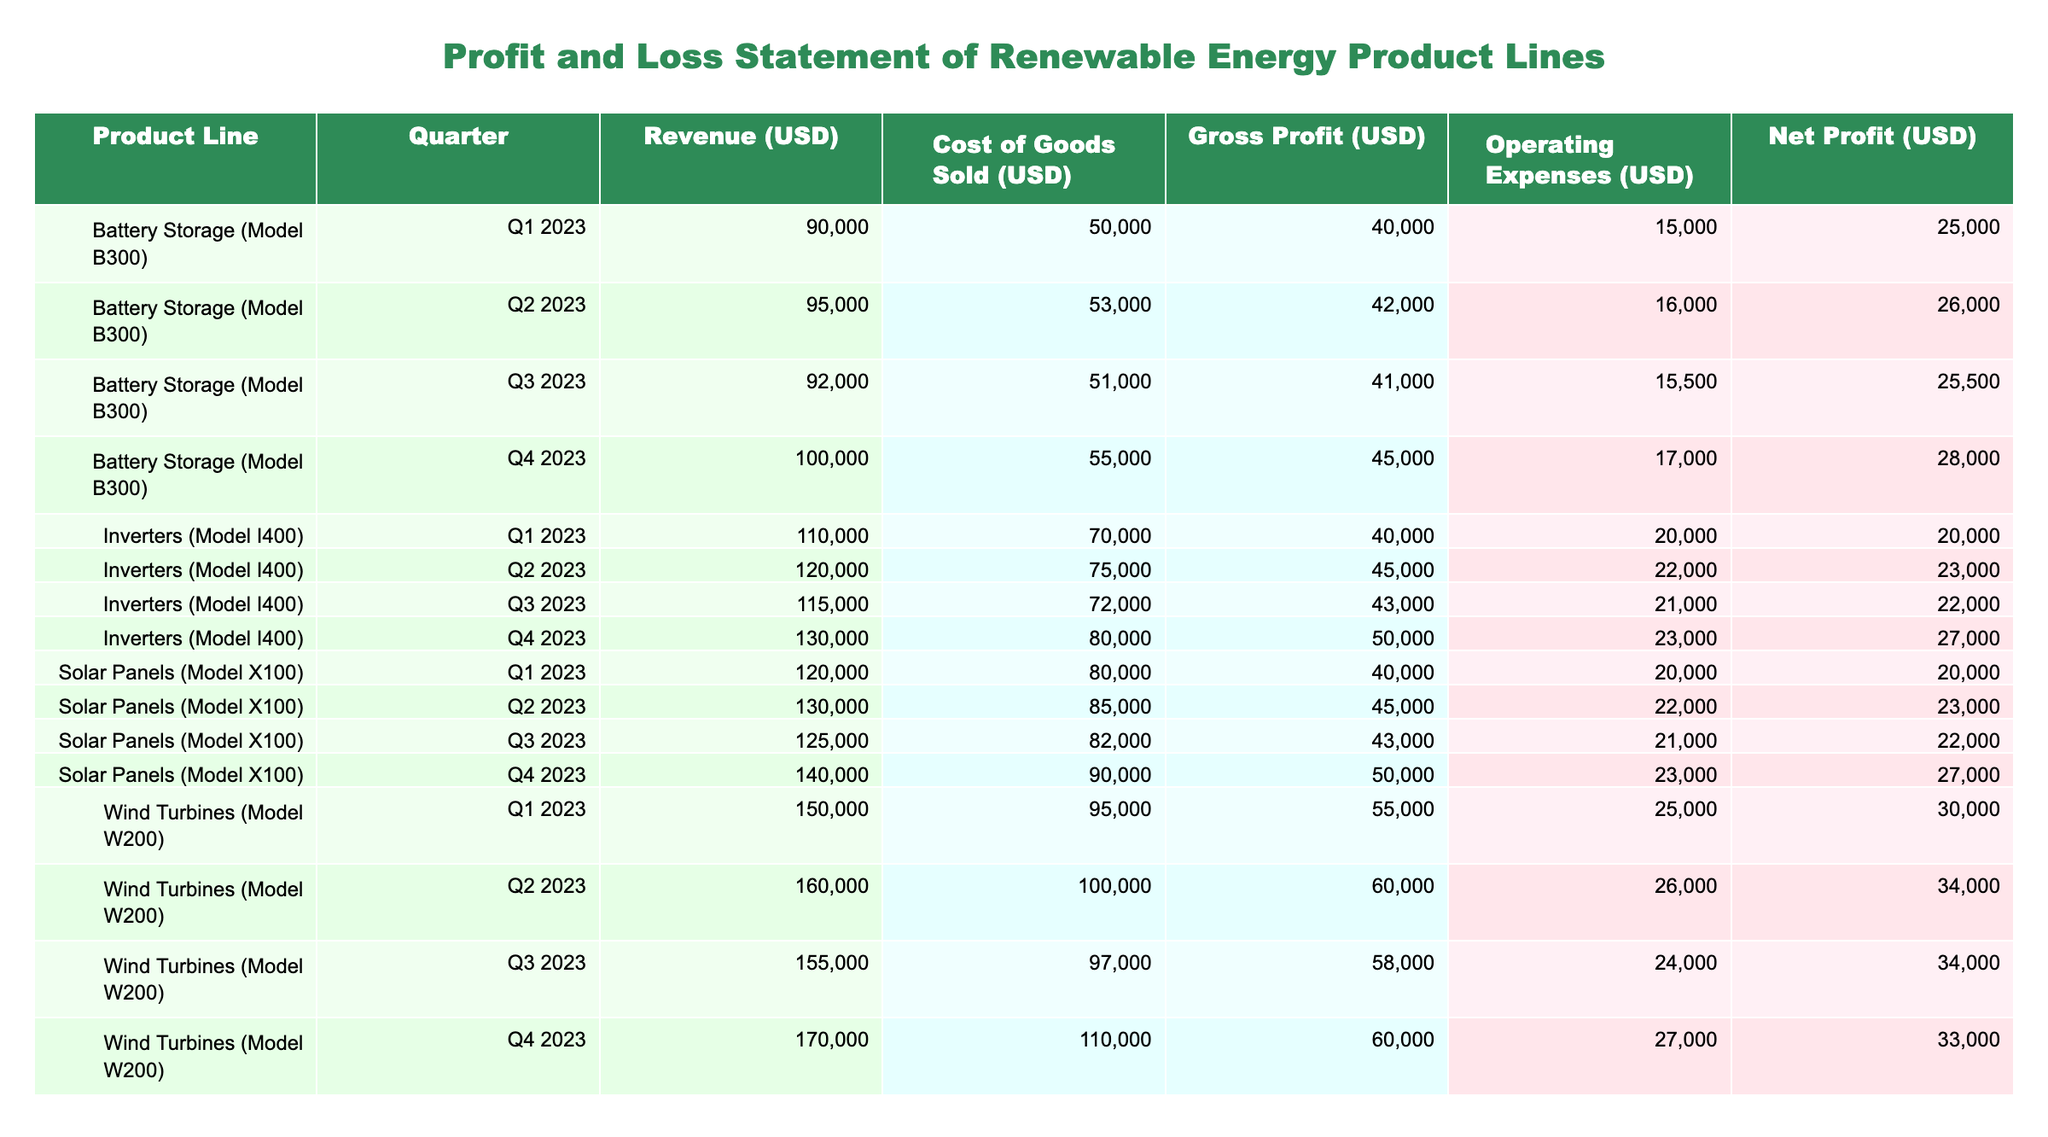What is the revenue of Wind Turbines (Model W200) in Q3 2023? From the table, I can find the entry for Wind Turbines (Model W200) in the column for Q3 2023, which shows a revenue of 155000 USD.
Answer: 155000 USD What was the net profit for Solar Panels (Model X100) in Q4 2023? Looking at the data for Solar Panels (Model X100) in Q4 2023, the net profit listed is 27000 USD.
Answer: 27000 USD What is the average gross profit for Battery Storage (Model B300) over Q1 to Q4 of 2023? I add up the gross profits for each quarter: 40000 + 42000 + 41000 + 45000 = 168000 USD. To find the average, I divide that sum by 4, resulting in 42000 USD.
Answer: 42000 USD Did the operating expenses for Inverters (Model I400) decrease from Q2 to Q3 in 2023? For Inverters (Model I400), Q2 operating expenses are 22000 USD and Q3 have them at 21000 USD. Since 21000 is less than 22000, the operating expenses did indeed decrease.
Answer: Yes Which product line had the highest net profit in Q2 2023? Reviewing the net profits for all product lines in Q2 2023: Solar Panels (23000), Wind Turbines (34000), Battery Storage (26000), and Inverters (23000). Wind Turbines showed the highest net profit of 34000 USD.
Answer: Wind Turbines (Model W200) What is the total revenue generated from Solar Panels (Model X100) throughout all quarters in 2023? The total revenue is calculated by adding the revenues from each quarter: 120000 + 130000 + 125000 + 140000 = 515000 USD.
Answer: 515000 USD Is the gross profit for Battery Storage (Model B300) higher in Q4 2023 than in Q1 2023? For Battery Storage (Model B300), gross profit in Q4 is 45000 USD and in Q1 is 40000 USD. Since 45000 is greater than 40000, the gross profit in Q4 2023 is higher.
Answer: Yes How much more did Wind Turbines (Model W200) earn in net profit than Solar Panels (Model X100) in Q3 2023? The net profit for Wind Turbines (Model W200) in Q3 2023 is 34000 USD and for Solar Panels (Model X100) it is 22000 USD. Subtracting these gives 34000 - 22000 = 12000 USD more for Wind Turbines.
Answer: 12000 USD In which quarter did Battery Storage (Model B300) experience the lowest operating expenses? Reviewing the operating expenses for Battery Storage across the quarters: Q1 (15000), Q2 (16000), Q3 (15500), and Q4 (17000). The lowest figure is 15000 USD in Q1 2023.
Answer: Q1 2023 